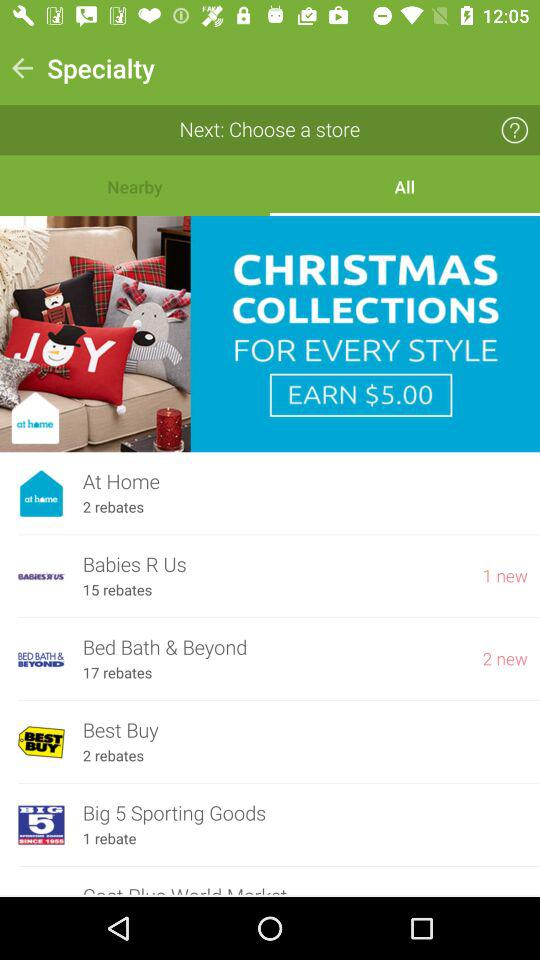What is the total number of rebates for "Best Buy"? The total number of rebates is 2. 